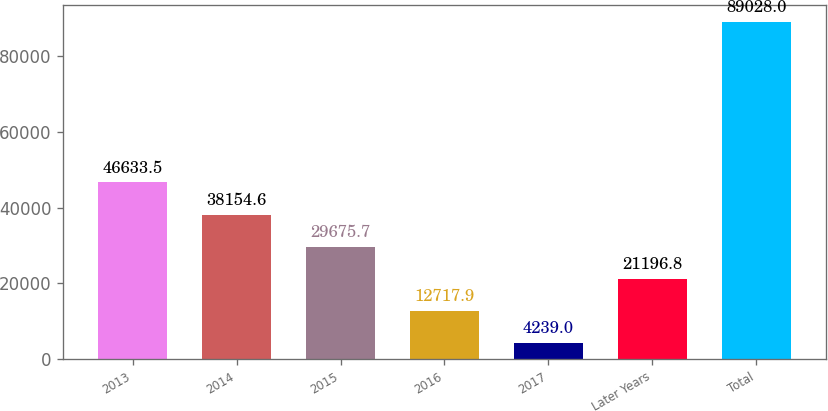Convert chart. <chart><loc_0><loc_0><loc_500><loc_500><bar_chart><fcel>2013<fcel>2014<fcel>2015<fcel>2016<fcel>2017<fcel>Later Years<fcel>Total<nl><fcel>46633.5<fcel>38154.6<fcel>29675.7<fcel>12717.9<fcel>4239<fcel>21196.8<fcel>89028<nl></chart> 